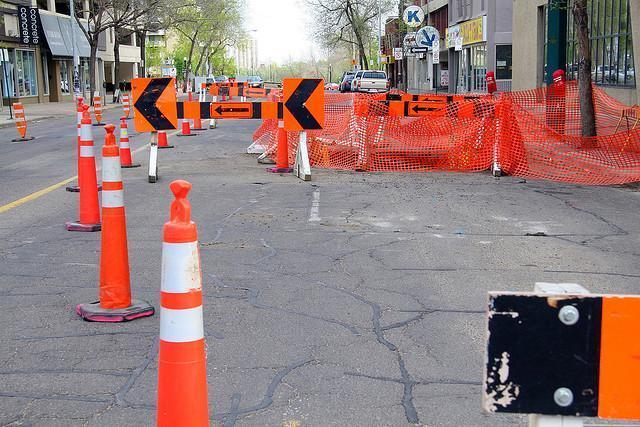How many total people are in this picture?
Give a very brief answer. 0. 